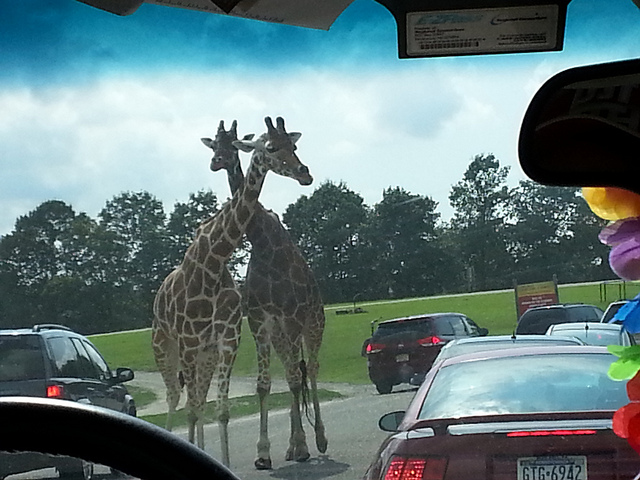Read all the text in this image. 616-6942 